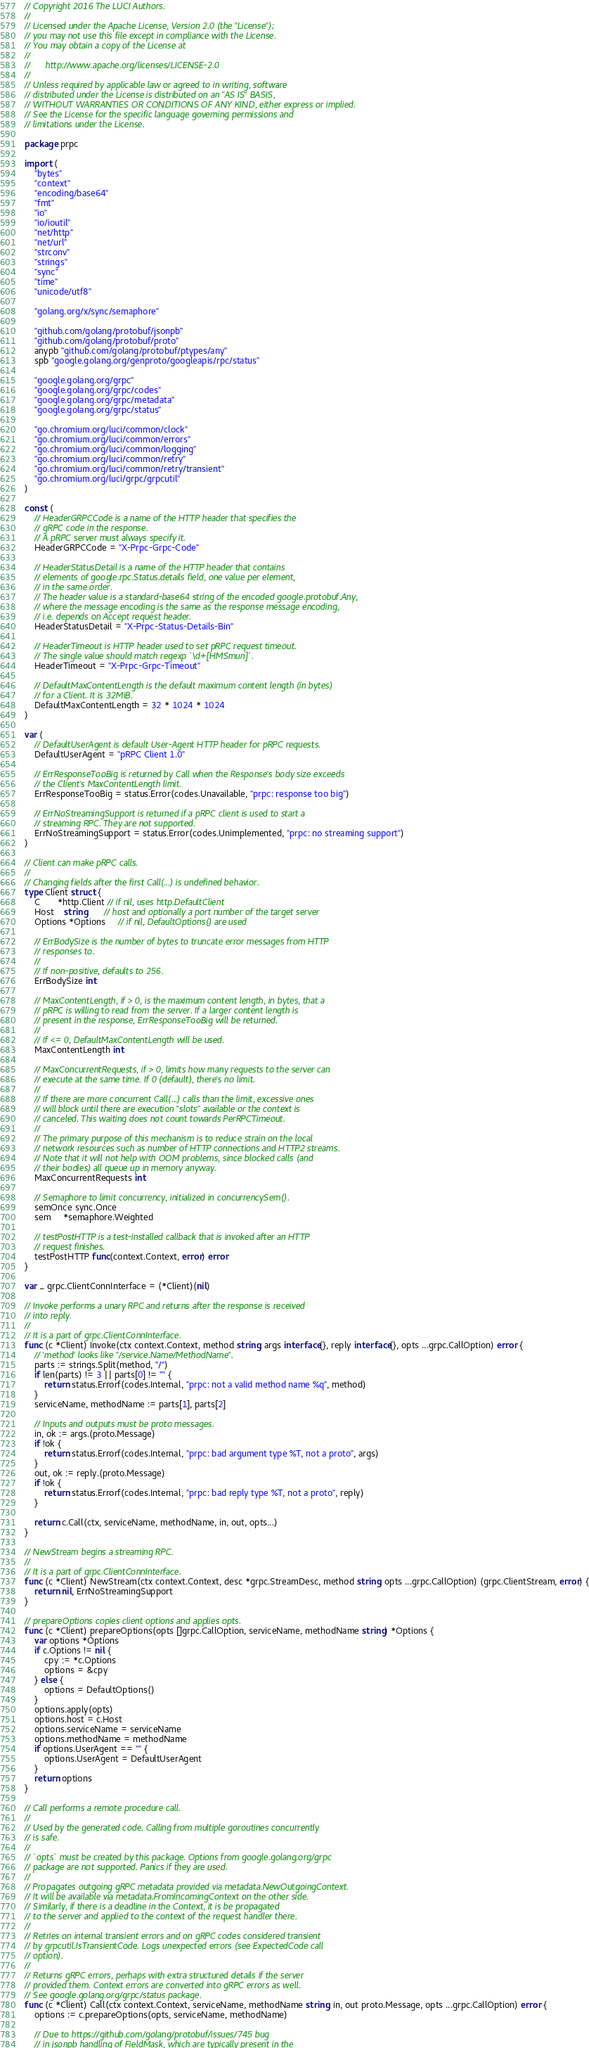Convert code to text. <code><loc_0><loc_0><loc_500><loc_500><_Go_>// Copyright 2016 The LUCI Authors.
//
// Licensed under the Apache License, Version 2.0 (the "License");
// you may not use this file except in compliance with the License.
// You may obtain a copy of the License at
//
//      http://www.apache.org/licenses/LICENSE-2.0
//
// Unless required by applicable law or agreed to in writing, software
// distributed under the License is distributed on an "AS IS" BASIS,
// WITHOUT WARRANTIES OR CONDITIONS OF ANY KIND, either express or implied.
// See the License for the specific language governing permissions and
// limitations under the License.

package prpc

import (
	"bytes"
	"context"
	"encoding/base64"
	"fmt"
	"io"
	"io/ioutil"
	"net/http"
	"net/url"
	"strconv"
	"strings"
	"sync"
	"time"
	"unicode/utf8"

	"golang.org/x/sync/semaphore"

	"github.com/golang/protobuf/jsonpb"
	"github.com/golang/protobuf/proto"
	anypb "github.com/golang/protobuf/ptypes/any"
	spb "google.golang.org/genproto/googleapis/rpc/status"

	"google.golang.org/grpc"
	"google.golang.org/grpc/codes"
	"google.golang.org/grpc/metadata"
	"google.golang.org/grpc/status"

	"go.chromium.org/luci/common/clock"
	"go.chromium.org/luci/common/errors"
	"go.chromium.org/luci/common/logging"
	"go.chromium.org/luci/common/retry"
	"go.chromium.org/luci/common/retry/transient"
	"go.chromium.org/luci/grpc/grpcutil"
)

const (
	// HeaderGRPCCode is a name of the HTTP header that specifies the
	// gRPC code in the response.
	// A pRPC server must always specify it.
	HeaderGRPCCode = "X-Prpc-Grpc-Code"

	// HeaderStatusDetail is a name of the HTTP header that contains
	// elements of google.rpc.Status.details field, one value per element,
	// in the same order.
	// The header value is a standard-base64 string of the encoded google.protobuf.Any,
	// where the message encoding is the same as the response message encoding,
	// i.e. depends on Accept request header.
	HeaderStatusDetail = "X-Prpc-Status-Details-Bin"

	// HeaderTimeout is HTTP header used to set pRPC request timeout.
	// The single value should match regexp `\d+[HMSmun]`.
	HeaderTimeout = "X-Prpc-Grpc-Timeout"

	// DefaultMaxContentLength is the default maximum content length (in bytes)
	// for a Client. It is 32MiB.
	DefaultMaxContentLength = 32 * 1024 * 1024
)

var (
	// DefaultUserAgent is default User-Agent HTTP header for pRPC requests.
	DefaultUserAgent = "pRPC Client 1.0"

	// ErrResponseTooBig is returned by Call when the Response's body size exceeds
	// the Client's MaxContentLength limit.
	ErrResponseTooBig = status.Error(codes.Unavailable, "prpc: response too big")

	// ErrNoStreamingSupport is returned if a pRPC client is used to start a
	// streaming RPC. They are not supported.
	ErrNoStreamingSupport = status.Error(codes.Unimplemented, "prpc: no streaming support")
)

// Client can make pRPC calls.
//
// Changing fields after the first Call(...) is undefined behavior.
type Client struct {
	C       *http.Client // if nil, uses http.DefaultClient
	Host    string       // host and optionally a port number of the target server
	Options *Options     // if nil, DefaultOptions() are used

	// ErrBodySize is the number of bytes to truncate error messages from HTTP
	// responses to.
	//
	// If non-positive, defaults to 256.
	ErrBodySize int

	// MaxContentLength, if > 0, is the maximum content length, in bytes, that a
	// pRPC is willing to read from the server. If a larger content length is
	// present in the response, ErrResponseTooBig will be returned.
	//
	// If <= 0, DefaultMaxContentLength will be used.
	MaxContentLength int

	// MaxConcurrentRequests, if > 0, limits how many requests to the server can
	// execute at the same time. If 0 (default), there's no limit.
	//
	// If there are more concurrent Call(...) calls than the limit, excessive ones
	// will block until there are execution "slots" available or the context is
	// canceled. This waiting does not count towards PerRPCTimeout.
	//
	// The primary purpose of this mechanism is to reduce strain on the local
	// network resources such as number of HTTP connections and HTTP2 streams.
	// Note that it will not help with OOM problems, since blocked calls (and
	// their bodies) all queue up in memory anyway.
	MaxConcurrentRequests int

	// Semaphore to limit concurrency, initialized in concurrencySem().
	semOnce sync.Once
	sem     *semaphore.Weighted

	// testPostHTTP is a test-installed callback that is invoked after an HTTP
	// request finishes.
	testPostHTTP func(context.Context, error) error
}

var _ grpc.ClientConnInterface = (*Client)(nil)

// Invoke performs a unary RPC and returns after the response is received
// into reply.
//
// It is a part of grpc.ClientConnInterface.
func (c *Client) Invoke(ctx context.Context, method string, args interface{}, reply interface{}, opts ...grpc.CallOption) error {
	// 'method' looks like "/service.Name/MethodName".
	parts := strings.Split(method, "/")
	if len(parts) != 3 || parts[0] != "" {
		return status.Errorf(codes.Internal, "prpc: not a valid method name %q", method)
	}
	serviceName, methodName := parts[1], parts[2]

	// Inputs and outputs must be proto messages.
	in, ok := args.(proto.Message)
	if !ok {
		return status.Errorf(codes.Internal, "prpc: bad argument type %T, not a proto", args)
	}
	out, ok := reply.(proto.Message)
	if !ok {
		return status.Errorf(codes.Internal, "prpc: bad reply type %T, not a proto", reply)
	}

	return c.Call(ctx, serviceName, methodName, in, out, opts...)
}

// NewStream begins a streaming RPC.
//
// It is a part of grpc.ClientConnInterface.
func (c *Client) NewStream(ctx context.Context, desc *grpc.StreamDesc, method string, opts ...grpc.CallOption) (grpc.ClientStream, error) {
	return nil, ErrNoStreamingSupport
}

// prepareOptions copies client options and applies opts.
func (c *Client) prepareOptions(opts []grpc.CallOption, serviceName, methodName string) *Options {
	var options *Options
	if c.Options != nil {
		cpy := *c.Options
		options = &cpy
	} else {
		options = DefaultOptions()
	}
	options.apply(opts)
	options.host = c.Host
	options.serviceName = serviceName
	options.methodName = methodName
	if options.UserAgent == "" {
		options.UserAgent = DefaultUserAgent
	}
	return options
}

// Call performs a remote procedure call.
//
// Used by the generated code. Calling from multiple goroutines concurrently
// is safe.
//
// `opts` must be created by this package. Options from google.golang.org/grpc
// package are not supported. Panics if they are used.
//
// Propagates outgoing gRPC metadata provided via metadata.NewOutgoingContext.
// It will be available via metadata.FromIncomingContext on the other side.
// Similarly, if there is a deadline in the Context, it is be propagated
// to the server and applied to the context of the request handler there.
//
// Retries on internal transient errors and on gRPC codes considered transient
// by grpcutil.IsTransientCode. Logs unexpected errors (see ExpectedCode call
// option).
//
// Returns gRPC errors, perhaps with extra structured details if the server
// provided them. Context errors are converted into gRPC errors as well.
// See google.golang.org/grpc/status package.
func (c *Client) Call(ctx context.Context, serviceName, methodName string, in, out proto.Message, opts ...grpc.CallOption) error {
	options := c.prepareOptions(opts, serviceName, methodName)

	// Due to https://github.com/golang/protobuf/issues/745 bug
	// in jsonpb handling of FieldMask, which are typically present in the</code> 